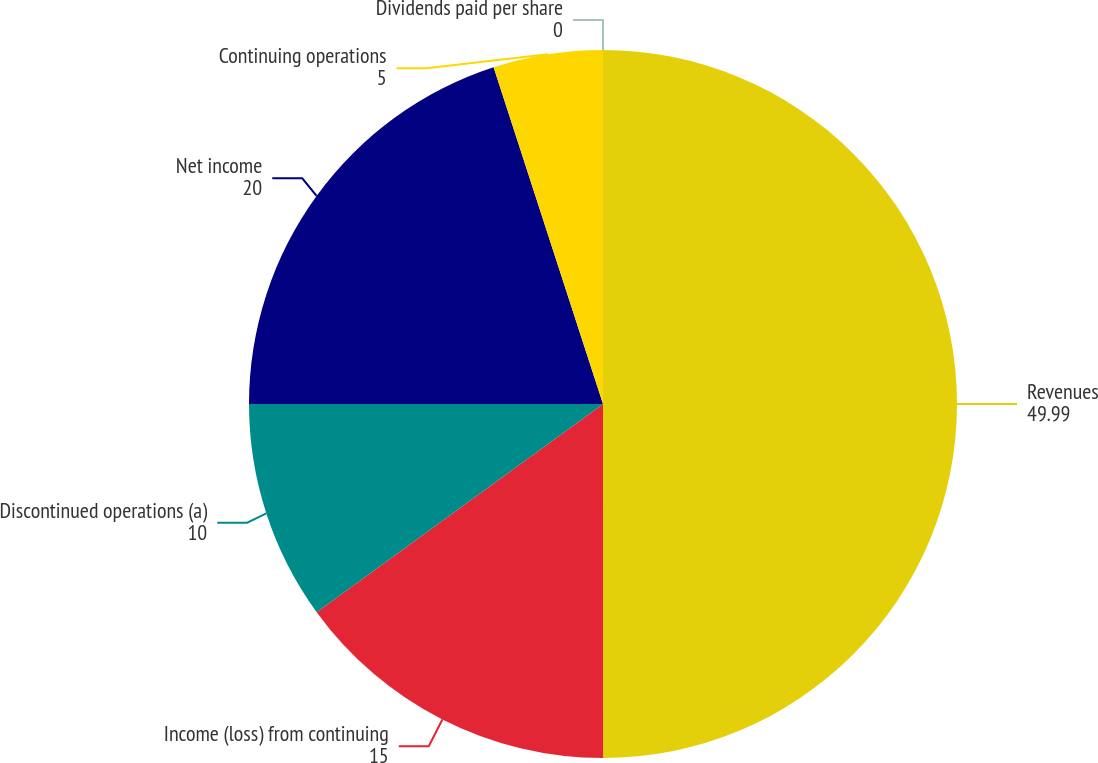Convert chart to OTSL. <chart><loc_0><loc_0><loc_500><loc_500><pie_chart><fcel>Revenues<fcel>Income (loss) from continuing<fcel>Discontinued operations (a)<fcel>Net income<fcel>Continuing operations<fcel>Dividends paid per share<nl><fcel>49.99%<fcel>15.0%<fcel>10.0%<fcel>20.0%<fcel>5.0%<fcel>0.0%<nl></chart> 